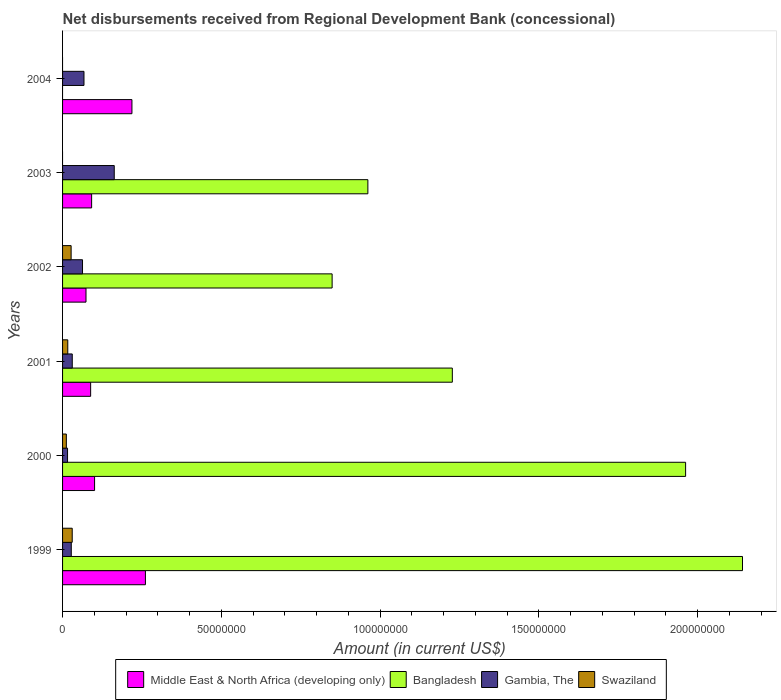Are the number of bars on each tick of the Y-axis equal?
Give a very brief answer. No. How many bars are there on the 4th tick from the bottom?
Your answer should be compact. 4. What is the label of the 6th group of bars from the top?
Your answer should be compact. 1999. In how many cases, is the number of bars for a given year not equal to the number of legend labels?
Keep it short and to the point. 2. What is the amount of disbursements received from Regional Development Bank in Middle East & North Africa (developing only) in 1999?
Your answer should be very brief. 2.61e+07. Across all years, what is the maximum amount of disbursements received from Regional Development Bank in Swaziland?
Your answer should be very brief. 3.04e+06. Across all years, what is the minimum amount of disbursements received from Regional Development Bank in Gambia, The?
Ensure brevity in your answer.  1.57e+06. In which year was the amount of disbursements received from Regional Development Bank in Gambia, The maximum?
Offer a very short reply. 2003. What is the total amount of disbursements received from Regional Development Bank in Swaziland in the graph?
Offer a very short reply. 8.57e+06. What is the difference between the amount of disbursements received from Regional Development Bank in Gambia, The in 2001 and that in 2004?
Offer a terse response. -3.69e+06. What is the difference between the amount of disbursements received from Regional Development Bank in Gambia, The in 2004 and the amount of disbursements received from Regional Development Bank in Swaziland in 2001?
Your answer should be very brief. 5.11e+06. What is the average amount of disbursements received from Regional Development Bank in Bangladesh per year?
Keep it short and to the point. 1.19e+08. In the year 2002, what is the difference between the amount of disbursements received from Regional Development Bank in Middle East & North Africa (developing only) and amount of disbursements received from Regional Development Bank in Swaziland?
Keep it short and to the point. 4.68e+06. What is the ratio of the amount of disbursements received from Regional Development Bank in Bangladesh in 2001 to that in 2002?
Your answer should be very brief. 1.45. Is the amount of disbursements received from Regional Development Bank in Gambia, The in 2000 less than that in 2002?
Ensure brevity in your answer.  Yes. What is the difference between the highest and the second highest amount of disbursements received from Regional Development Bank in Gambia, The?
Give a very brief answer. 9.53e+06. What is the difference between the highest and the lowest amount of disbursements received from Regional Development Bank in Bangladesh?
Give a very brief answer. 2.14e+08. Is it the case that in every year, the sum of the amount of disbursements received from Regional Development Bank in Swaziland and amount of disbursements received from Regional Development Bank in Gambia, The is greater than the sum of amount of disbursements received from Regional Development Bank in Middle East & North Africa (developing only) and amount of disbursements received from Regional Development Bank in Bangladesh?
Your answer should be very brief. Yes. How many years are there in the graph?
Your response must be concise. 6. Are the values on the major ticks of X-axis written in scientific E-notation?
Your response must be concise. No. Does the graph contain any zero values?
Make the answer very short. Yes. How many legend labels are there?
Provide a short and direct response. 4. What is the title of the graph?
Offer a very short reply. Net disbursements received from Regional Development Bank (concessional). What is the Amount (in current US$) in Middle East & North Africa (developing only) in 1999?
Your response must be concise. 2.61e+07. What is the Amount (in current US$) in Bangladesh in 1999?
Give a very brief answer. 2.14e+08. What is the Amount (in current US$) in Gambia, The in 1999?
Keep it short and to the point. 2.75e+06. What is the Amount (in current US$) in Swaziland in 1999?
Your answer should be very brief. 3.04e+06. What is the Amount (in current US$) in Middle East & North Africa (developing only) in 2000?
Keep it short and to the point. 1.01e+07. What is the Amount (in current US$) of Bangladesh in 2000?
Ensure brevity in your answer.  1.96e+08. What is the Amount (in current US$) of Gambia, The in 2000?
Give a very brief answer. 1.57e+06. What is the Amount (in current US$) of Swaziland in 2000?
Offer a terse response. 1.19e+06. What is the Amount (in current US$) of Middle East & North Africa (developing only) in 2001?
Offer a terse response. 8.84e+06. What is the Amount (in current US$) in Bangladesh in 2001?
Your response must be concise. 1.23e+08. What is the Amount (in current US$) of Gambia, The in 2001?
Your response must be concise. 3.06e+06. What is the Amount (in current US$) in Swaziland in 2001?
Your answer should be compact. 1.64e+06. What is the Amount (in current US$) of Middle East & North Africa (developing only) in 2002?
Provide a succinct answer. 7.38e+06. What is the Amount (in current US$) of Bangladesh in 2002?
Make the answer very short. 8.49e+07. What is the Amount (in current US$) in Gambia, The in 2002?
Offer a very short reply. 6.28e+06. What is the Amount (in current US$) of Swaziland in 2002?
Ensure brevity in your answer.  2.70e+06. What is the Amount (in current US$) of Middle East & North Africa (developing only) in 2003?
Make the answer very short. 9.15e+06. What is the Amount (in current US$) of Bangladesh in 2003?
Your answer should be compact. 9.61e+07. What is the Amount (in current US$) in Gambia, The in 2003?
Give a very brief answer. 1.63e+07. What is the Amount (in current US$) of Middle East & North Africa (developing only) in 2004?
Your answer should be very brief. 2.18e+07. What is the Amount (in current US$) in Gambia, The in 2004?
Keep it short and to the point. 6.75e+06. What is the Amount (in current US$) in Swaziland in 2004?
Offer a very short reply. 0. Across all years, what is the maximum Amount (in current US$) in Middle East & North Africa (developing only)?
Your answer should be very brief. 2.61e+07. Across all years, what is the maximum Amount (in current US$) of Bangladesh?
Make the answer very short. 2.14e+08. Across all years, what is the maximum Amount (in current US$) in Gambia, The?
Offer a very short reply. 1.63e+07. Across all years, what is the maximum Amount (in current US$) of Swaziland?
Keep it short and to the point. 3.04e+06. Across all years, what is the minimum Amount (in current US$) in Middle East & North Africa (developing only)?
Your response must be concise. 7.38e+06. Across all years, what is the minimum Amount (in current US$) in Bangladesh?
Offer a terse response. 0. Across all years, what is the minimum Amount (in current US$) of Gambia, The?
Your answer should be very brief. 1.57e+06. What is the total Amount (in current US$) in Middle East & North Africa (developing only) in the graph?
Your answer should be very brief. 8.34e+07. What is the total Amount (in current US$) of Bangladesh in the graph?
Your answer should be compact. 7.14e+08. What is the total Amount (in current US$) of Gambia, The in the graph?
Provide a succinct answer. 3.67e+07. What is the total Amount (in current US$) in Swaziland in the graph?
Provide a short and direct response. 8.57e+06. What is the difference between the Amount (in current US$) of Middle East & North Africa (developing only) in 1999 and that in 2000?
Provide a succinct answer. 1.60e+07. What is the difference between the Amount (in current US$) in Bangladesh in 1999 and that in 2000?
Offer a terse response. 1.79e+07. What is the difference between the Amount (in current US$) of Gambia, The in 1999 and that in 2000?
Offer a very short reply. 1.18e+06. What is the difference between the Amount (in current US$) of Swaziland in 1999 and that in 2000?
Provide a succinct answer. 1.85e+06. What is the difference between the Amount (in current US$) in Middle East & North Africa (developing only) in 1999 and that in 2001?
Ensure brevity in your answer.  1.72e+07. What is the difference between the Amount (in current US$) of Bangladesh in 1999 and that in 2001?
Offer a very short reply. 9.14e+07. What is the difference between the Amount (in current US$) of Gambia, The in 1999 and that in 2001?
Keep it short and to the point. -3.10e+05. What is the difference between the Amount (in current US$) of Swaziland in 1999 and that in 2001?
Your answer should be very brief. 1.40e+06. What is the difference between the Amount (in current US$) of Middle East & North Africa (developing only) in 1999 and that in 2002?
Your response must be concise. 1.87e+07. What is the difference between the Amount (in current US$) in Bangladesh in 1999 and that in 2002?
Provide a short and direct response. 1.29e+08. What is the difference between the Amount (in current US$) in Gambia, The in 1999 and that in 2002?
Make the answer very short. -3.54e+06. What is the difference between the Amount (in current US$) in Swaziland in 1999 and that in 2002?
Offer a very short reply. 3.47e+05. What is the difference between the Amount (in current US$) in Middle East & North Africa (developing only) in 1999 and that in 2003?
Provide a short and direct response. 1.69e+07. What is the difference between the Amount (in current US$) of Bangladesh in 1999 and that in 2003?
Give a very brief answer. 1.18e+08. What is the difference between the Amount (in current US$) in Gambia, The in 1999 and that in 2003?
Make the answer very short. -1.35e+07. What is the difference between the Amount (in current US$) of Middle East & North Africa (developing only) in 1999 and that in 2004?
Offer a very short reply. 4.25e+06. What is the difference between the Amount (in current US$) of Gambia, The in 1999 and that in 2004?
Offer a terse response. -4.00e+06. What is the difference between the Amount (in current US$) in Middle East & North Africa (developing only) in 2000 and that in 2001?
Your answer should be compact. 1.24e+06. What is the difference between the Amount (in current US$) in Bangladesh in 2000 and that in 2001?
Your answer should be very brief. 7.35e+07. What is the difference between the Amount (in current US$) in Gambia, The in 2000 and that in 2001?
Provide a succinct answer. -1.48e+06. What is the difference between the Amount (in current US$) of Swaziland in 2000 and that in 2001?
Provide a short and direct response. -4.48e+05. What is the difference between the Amount (in current US$) in Middle East & North Africa (developing only) in 2000 and that in 2002?
Your answer should be very brief. 2.70e+06. What is the difference between the Amount (in current US$) of Bangladesh in 2000 and that in 2002?
Provide a short and direct response. 1.11e+08. What is the difference between the Amount (in current US$) in Gambia, The in 2000 and that in 2002?
Offer a very short reply. -4.71e+06. What is the difference between the Amount (in current US$) of Swaziland in 2000 and that in 2002?
Your answer should be compact. -1.50e+06. What is the difference between the Amount (in current US$) of Middle East & North Africa (developing only) in 2000 and that in 2003?
Give a very brief answer. 9.26e+05. What is the difference between the Amount (in current US$) of Bangladesh in 2000 and that in 2003?
Offer a very short reply. 1.00e+08. What is the difference between the Amount (in current US$) in Gambia, The in 2000 and that in 2003?
Make the answer very short. -1.47e+07. What is the difference between the Amount (in current US$) of Middle East & North Africa (developing only) in 2000 and that in 2004?
Offer a terse response. -1.18e+07. What is the difference between the Amount (in current US$) in Gambia, The in 2000 and that in 2004?
Provide a succinct answer. -5.18e+06. What is the difference between the Amount (in current US$) of Middle East & North Africa (developing only) in 2001 and that in 2002?
Your answer should be very brief. 1.46e+06. What is the difference between the Amount (in current US$) in Bangladesh in 2001 and that in 2002?
Your answer should be compact. 3.79e+07. What is the difference between the Amount (in current US$) of Gambia, The in 2001 and that in 2002?
Your answer should be compact. -3.22e+06. What is the difference between the Amount (in current US$) in Swaziland in 2001 and that in 2002?
Give a very brief answer. -1.06e+06. What is the difference between the Amount (in current US$) in Middle East & North Africa (developing only) in 2001 and that in 2003?
Ensure brevity in your answer.  -3.10e+05. What is the difference between the Amount (in current US$) of Bangladesh in 2001 and that in 2003?
Make the answer very short. 2.66e+07. What is the difference between the Amount (in current US$) of Gambia, The in 2001 and that in 2003?
Make the answer very short. -1.32e+07. What is the difference between the Amount (in current US$) of Middle East & North Africa (developing only) in 2001 and that in 2004?
Offer a terse response. -1.30e+07. What is the difference between the Amount (in current US$) in Gambia, The in 2001 and that in 2004?
Make the answer very short. -3.69e+06. What is the difference between the Amount (in current US$) of Middle East & North Africa (developing only) in 2002 and that in 2003?
Provide a short and direct response. -1.77e+06. What is the difference between the Amount (in current US$) of Bangladesh in 2002 and that in 2003?
Make the answer very short. -1.13e+07. What is the difference between the Amount (in current US$) of Gambia, The in 2002 and that in 2003?
Your answer should be compact. -9.99e+06. What is the difference between the Amount (in current US$) of Middle East & North Africa (developing only) in 2002 and that in 2004?
Your answer should be compact. -1.45e+07. What is the difference between the Amount (in current US$) in Gambia, The in 2002 and that in 2004?
Offer a terse response. -4.66e+05. What is the difference between the Amount (in current US$) in Middle East & North Africa (developing only) in 2003 and that in 2004?
Your answer should be compact. -1.27e+07. What is the difference between the Amount (in current US$) in Gambia, The in 2003 and that in 2004?
Your answer should be very brief. 9.53e+06. What is the difference between the Amount (in current US$) in Middle East & North Africa (developing only) in 1999 and the Amount (in current US$) in Bangladesh in 2000?
Your response must be concise. -1.70e+08. What is the difference between the Amount (in current US$) in Middle East & North Africa (developing only) in 1999 and the Amount (in current US$) in Gambia, The in 2000?
Provide a short and direct response. 2.45e+07. What is the difference between the Amount (in current US$) in Middle East & North Africa (developing only) in 1999 and the Amount (in current US$) in Swaziland in 2000?
Provide a short and direct response. 2.49e+07. What is the difference between the Amount (in current US$) of Bangladesh in 1999 and the Amount (in current US$) of Gambia, The in 2000?
Your answer should be very brief. 2.13e+08. What is the difference between the Amount (in current US$) in Bangladesh in 1999 and the Amount (in current US$) in Swaziland in 2000?
Ensure brevity in your answer.  2.13e+08. What is the difference between the Amount (in current US$) of Gambia, The in 1999 and the Amount (in current US$) of Swaziland in 2000?
Keep it short and to the point. 1.55e+06. What is the difference between the Amount (in current US$) in Middle East & North Africa (developing only) in 1999 and the Amount (in current US$) in Bangladesh in 2001?
Provide a short and direct response. -9.66e+07. What is the difference between the Amount (in current US$) of Middle East & North Africa (developing only) in 1999 and the Amount (in current US$) of Gambia, The in 2001?
Your answer should be very brief. 2.30e+07. What is the difference between the Amount (in current US$) in Middle East & North Africa (developing only) in 1999 and the Amount (in current US$) in Swaziland in 2001?
Offer a very short reply. 2.45e+07. What is the difference between the Amount (in current US$) in Bangladesh in 1999 and the Amount (in current US$) in Gambia, The in 2001?
Your answer should be very brief. 2.11e+08. What is the difference between the Amount (in current US$) in Bangladesh in 1999 and the Amount (in current US$) in Swaziland in 2001?
Offer a very short reply. 2.12e+08. What is the difference between the Amount (in current US$) of Gambia, The in 1999 and the Amount (in current US$) of Swaziland in 2001?
Keep it short and to the point. 1.11e+06. What is the difference between the Amount (in current US$) of Middle East & North Africa (developing only) in 1999 and the Amount (in current US$) of Bangladesh in 2002?
Your response must be concise. -5.88e+07. What is the difference between the Amount (in current US$) of Middle East & North Africa (developing only) in 1999 and the Amount (in current US$) of Gambia, The in 2002?
Provide a succinct answer. 1.98e+07. What is the difference between the Amount (in current US$) in Middle East & North Africa (developing only) in 1999 and the Amount (in current US$) in Swaziland in 2002?
Keep it short and to the point. 2.34e+07. What is the difference between the Amount (in current US$) in Bangladesh in 1999 and the Amount (in current US$) in Gambia, The in 2002?
Provide a succinct answer. 2.08e+08. What is the difference between the Amount (in current US$) in Bangladesh in 1999 and the Amount (in current US$) in Swaziland in 2002?
Provide a succinct answer. 2.11e+08. What is the difference between the Amount (in current US$) in Gambia, The in 1999 and the Amount (in current US$) in Swaziland in 2002?
Your response must be concise. 5.10e+04. What is the difference between the Amount (in current US$) of Middle East & North Africa (developing only) in 1999 and the Amount (in current US$) of Bangladesh in 2003?
Provide a succinct answer. -7.01e+07. What is the difference between the Amount (in current US$) in Middle East & North Africa (developing only) in 1999 and the Amount (in current US$) in Gambia, The in 2003?
Ensure brevity in your answer.  9.82e+06. What is the difference between the Amount (in current US$) in Bangladesh in 1999 and the Amount (in current US$) in Gambia, The in 2003?
Offer a very short reply. 1.98e+08. What is the difference between the Amount (in current US$) of Middle East & North Africa (developing only) in 1999 and the Amount (in current US$) of Gambia, The in 2004?
Provide a short and direct response. 1.93e+07. What is the difference between the Amount (in current US$) in Bangladesh in 1999 and the Amount (in current US$) in Gambia, The in 2004?
Give a very brief answer. 2.07e+08. What is the difference between the Amount (in current US$) of Middle East & North Africa (developing only) in 2000 and the Amount (in current US$) of Bangladesh in 2001?
Your answer should be very brief. -1.13e+08. What is the difference between the Amount (in current US$) of Middle East & North Africa (developing only) in 2000 and the Amount (in current US$) of Gambia, The in 2001?
Make the answer very short. 7.02e+06. What is the difference between the Amount (in current US$) in Middle East & North Africa (developing only) in 2000 and the Amount (in current US$) in Swaziland in 2001?
Offer a terse response. 8.44e+06. What is the difference between the Amount (in current US$) of Bangladesh in 2000 and the Amount (in current US$) of Gambia, The in 2001?
Give a very brief answer. 1.93e+08. What is the difference between the Amount (in current US$) of Bangladesh in 2000 and the Amount (in current US$) of Swaziland in 2001?
Offer a very short reply. 1.95e+08. What is the difference between the Amount (in current US$) of Gambia, The in 2000 and the Amount (in current US$) of Swaziland in 2001?
Make the answer very short. -6.90e+04. What is the difference between the Amount (in current US$) of Middle East & North Africa (developing only) in 2000 and the Amount (in current US$) of Bangladesh in 2002?
Make the answer very short. -7.48e+07. What is the difference between the Amount (in current US$) in Middle East & North Africa (developing only) in 2000 and the Amount (in current US$) in Gambia, The in 2002?
Give a very brief answer. 3.80e+06. What is the difference between the Amount (in current US$) of Middle East & North Africa (developing only) in 2000 and the Amount (in current US$) of Swaziland in 2002?
Your answer should be compact. 7.38e+06. What is the difference between the Amount (in current US$) in Bangladesh in 2000 and the Amount (in current US$) in Gambia, The in 2002?
Ensure brevity in your answer.  1.90e+08. What is the difference between the Amount (in current US$) of Bangladesh in 2000 and the Amount (in current US$) of Swaziland in 2002?
Offer a terse response. 1.94e+08. What is the difference between the Amount (in current US$) in Gambia, The in 2000 and the Amount (in current US$) in Swaziland in 2002?
Provide a short and direct response. -1.12e+06. What is the difference between the Amount (in current US$) in Middle East & North Africa (developing only) in 2000 and the Amount (in current US$) in Bangladesh in 2003?
Ensure brevity in your answer.  -8.61e+07. What is the difference between the Amount (in current US$) of Middle East & North Africa (developing only) in 2000 and the Amount (in current US$) of Gambia, The in 2003?
Offer a very short reply. -6.20e+06. What is the difference between the Amount (in current US$) in Bangladesh in 2000 and the Amount (in current US$) in Gambia, The in 2003?
Your response must be concise. 1.80e+08. What is the difference between the Amount (in current US$) of Middle East & North Africa (developing only) in 2000 and the Amount (in current US$) of Gambia, The in 2004?
Your answer should be compact. 3.33e+06. What is the difference between the Amount (in current US$) of Bangladesh in 2000 and the Amount (in current US$) of Gambia, The in 2004?
Offer a very short reply. 1.89e+08. What is the difference between the Amount (in current US$) of Middle East & North Africa (developing only) in 2001 and the Amount (in current US$) of Bangladesh in 2002?
Offer a very short reply. -7.60e+07. What is the difference between the Amount (in current US$) in Middle East & North Africa (developing only) in 2001 and the Amount (in current US$) in Gambia, The in 2002?
Provide a succinct answer. 2.56e+06. What is the difference between the Amount (in current US$) of Middle East & North Africa (developing only) in 2001 and the Amount (in current US$) of Swaziland in 2002?
Your answer should be compact. 6.15e+06. What is the difference between the Amount (in current US$) of Bangladesh in 2001 and the Amount (in current US$) of Gambia, The in 2002?
Provide a short and direct response. 1.16e+08. What is the difference between the Amount (in current US$) in Bangladesh in 2001 and the Amount (in current US$) in Swaziland in 2002?
Your response must be concise. 1.20e+08. What is the difference between the Amount (in current US$) of Gambia, The in 2001 and the Amount (in current US$) of Swaziland in 2002?
Give a very brief answer. 3.61e+05. What is the difference between the Amount (in current US$) in Middle East & North Africa (developing only) in 2001 and the Amount (in current US$) in Bangladesh in 2003?
Your answer should be very brief. -8.73e+07. What is the difference between the Amount (in current US$) in Middle East & North Africa (developing only) in 2001 and the Amount (in current US$) in Gambia, The in 2003?
Provide a succinct answer. -7.43e+06. What is the difference between the Amount (in current US$) of Bangladesh in 2001 and the Amount (in current US$) of Gambia, The in 2003?
Your answer should be compact. 1.06e+08. What is the difference between the Amount (in current US$) of Middle East & North Africa (developing only) in 2001 and the Amount (in current US$) of Gambia, The in 2004?
Ensure brevity in your answer.  2.10e+06. What is the difference between the Amount (in current US$) of Bangladesh in 2001 and the Amount (in current US$) of Gambia, The in 2004?
Ensure brevity in your answer.  1.16e+08. What is the difference between the Amount (in current US$) in Middle East & North Africa (developing only) in 2002 and the Amount (in current US$) in Bangladesh in 2003?
Provide a succinct answer. -8.88e+07. What is the difference between the Amount (in current US$) in Middle East & North Africa (developing only) in 2002 and the Amount (in current US$) in Gambia, The in 2003?
Give a very brief answer. -8.90e+06. What is the difference between the Amount (in current US$) of Bangladesh in 2002 and the Amount (in current US$) of Gambia, The in 2003?
Make the answer very short. 6.86e+07. What is the difference between the Amount (in current US$) of Middle East & North Africa (developing only) in 2002 and the Amount (in current US$) of Gambia, The in 2004?
Provide a succinct answer. 6.32e+05. What is the difference between the Amount (in current US$) in Bangladesh in 2002 and the Amount (in current US$) in Gambia, The in 2004?
Offer a very short reply. 7.81e+07. What is the difference between the Amount (in current US$) in Middle East & North Africa (developing only) in 2003 and the Amount (in current US$) in Gambia, The in 2004?
Provide a short and direct response. 2.41e+06. What is the difference between the Amount (in current US$) of Bangladesh in 2003 and the Amount (in current US$) of Gambia, The in 2004?
Your answer should be compact. 8.94e+07. What is the average Amount (in current US$) of Middle East & North Africa (developing only) per year?
Keep it short and to the point. 1.39e+07. What is the average Amount (in current US$) in Bangladesh per year?
Ensure brevity in your answer.  1.19e+08. What is the average Amount (in current US$) in Gambia, The per year?
Make the answer very short. 6.11e+06. What is the average Amount (in current US$) of Swaziland per year?
Your response must be concise. 1.43e+06. In the year 1999, what is the difference between the Amount (in current US$) in Middle East & North Africa (developing only) and Amount (in current US$) in Bangladesh?
Make the answer very short. -1.88e+08. In the year 1999, what is the difference between the Amount (in current US$) in Middle East & North Africa (developing only) and Amount (in current US$) in Gambia, The?
Provide a succinct answer. 2.33e+07. In the year 1999, what is the difference between the Amount (in current US$) of Middle East & North Africa (developing only) and Amount (in current US$) of Swaziland?
Make the answer very short. 2.31e+07. In the year 1999, what is the difference between the Amount (in current US$) of Bangladesh and Amount (in current US$) of Gambia, The?
Your answer should be very brief. 2.11e+08. In the year 1999, what is the difference between the Amount (in current US$) of Bangladesh and Amount (in current US$) of Swaziland?
Make the answer very short. 2.11e+08. In the year 1999, what is the difference between the Amount (in current US$) in Gambia, The and Amount (in current US$) in Swaziland?
Provide a short and direct response. -2.96e+05. In the year 2000, what is the difference between the Amount (in current US$) of Middle East & North Africa (developing only) and Amount (in current US$) of Bangladesh?
Ensure brevity in your answer.  -1.86e+08. In the year 2000, what is the difference between the Amount (in current US$) of Middle East & North Africa (developing only) and Amount (in current US$) of Gambia, The?
Give a very brief answer. 8.51e+06. In the year 2000, what is the difference between the Amount (in current US$) of Middle East & North Africa (developing only) and Amount (in current US$) of Swaziland?
Keep it short and to the point. 8.89e+06. In the year 2000, what is the difference between the Amount (in current US$) of Bangladesh and Amount (in current US$) of Gambia, The?
Offer a very short reply. 1.95e+08. In the year 2000, what is the difference between the Amount (in current US$) in Bangladesh and Amount (in current US$) in Swaziland?
Provide a succinct answer. 1.95e+08. In the year 2000, what is the difference between the Amount (in current US$) in Gambia, The and Amount (in current US$) in Swaziland?
Offer a terse response. 3.79e+05. In the year 2001, what is the difference between the Amount (in current US$) in Middle East & North Africa (developing only) and Amount (in current US$) in Bangladesh?
Your response must be concise. -1.14e+08. In the year 2001, what is the difference between the Amount (in current US$) of Middle East & North Africa (developing only) and Amount (in current US$) of Gambia, The?
Your answer should be compact. 5.79e+06. In the year 2001, what is the difference between the Amount (in current US$) of Middle East & North Africa (developing only) and Amount (in current US$) of Swaziland?
Provide a succinct answer. 7.20e+06. In the year 2001, what is the difference between the Amount (in current US$) in Bangladesh and Amount (in current US$) in Gambia, The?
Offer a terse response. 1.20e+08. In the year 2001, what is the difference between the Amount (in current US$) of Bangladesh and Amount (in current US$) of Swaziland?
Provide a short and direct response. 1.21e+08. In the year 2001, what is the difference between the Amount (in current US$) in Gambia, The and Amount (in current US$) in Swaziland?
Your response must be concise. 1.42e+06. In the year 2002, what is the difference between the Amount (in current US$) in Middle East & North Africa (developing only) and Amount (in current US$) in Bangladesh?
Keep it short and to the point. -7.75e+07. In the year 2002, what is the difference between the Amount (in current US$) in Middle East & North Africa (developing only) and Amount (in current US$) in Gambia, The?
Keep it short and to the point. 1.10e+06. In the year 2002, what is the difference between the Amount (in current US$) of Middle East & North Africa (developing only) and Amount (in current US$) of Swaziland?
Provide a short and direct response. 4.68e+06. In the year 2002, what is the difference between the Amount (in current US$) of Bangladesh and Amount (in current US$) of Gambia, The?
Keep it short and to the point. 7.86e+07. In the year 2002, what is the difference between the Amount (in current US$) of Bangladesh and Amount (in current US$) of Swaziland?
Offer a terse response. 8.22e+07. In the year 2002, what is the difference between the Amount (in current US$) of Gambia, The and Amount (in current US$) of Swaziland?
Keep it short and to the point. 3.59e+06. In the year 2003, what is the difference between the Amount (in current US$) in Middle East & North Africa (developing only) and Amount (in current US$) in Bangladesh?
Provide a short and direct response. -8.70e+07. In the year 2003, what is the difference between the Amount (in current US$) of Middle East & North Africa (developing only) and Amount (in current US$) of Gambia, The?
Keep it short and to the point. -7.12e+06. In the year 2003, what is the difference between the Amount (in current US$) of Bangladesh and Amount (in current US$) of Gambia, The?
Keep it short and to the point. 7.99e+07. In the year 2004, what is the difference between the Amount (in current US$) in Middle East & North Africa (developing only) and Amount (in current US$) in Gambia, The?
Give a very brief answer. 1.51e+07. What is the ratio of the Amount (in current US$) of Middle East & North Africa (developing only) in 1999 to that in 2000?
Give a very brief answer. 2.59. What is the ratio of the Amount (in current US$) in Bangladesh in 1999 to that in 2000?
Provide a succinct answer. 1.09. What is the ratio of the Amount (in current US$) in Gambia, The in 1999 to that in 2000?
Provide a short and direct response. 1.75. What is the ratio of the Amount (in current US$) of Swaziland in 1999 to that in 2000?
Offer a very short reply. 2.55. What is the ratio of the Amount (in current US$) in Middle East & North Africa (developing only) in 1999 to that in 2001?
Your answer should be compact. 2.95. What is the ratio of the Amount (in current US$) in Bangladesh in 1999 to that in 2001?
Make the answer very short. 1.74. What is the ratio of the Amount (in current US$) of Gambia, The in 1999 to that in 2001?
Provide a short and direct response. 0.9. What is the ratio of the Amount (in current US$) of Swaziland in 1999 to that in 2001?
Give a very brief answer. 1.85. What is the ratio of the Amount (in current US$) of Middle East & North Africa (developing only) in 1999 to that in 2002?
Your answer should be very brief. 3.54. What is the ratio of the Amount (in current US$) in Bangladesh in 1999 to that in 2002?
Offer a very short reply. 2.52. What is the ratio of the Amount (in current US$) of Gambia, The in 1999 to that in 2002?
Your answer should be very brief. 0.44. What is the ratio of the Amount (in current US$) in Swaziland in 1999 to that in 2002?
Provide a succinct answer. 1.13. What is the ratio of the Amount (in current US$) of Middle East & North Africa (developing only) in 1999 to that in 2003?
Offer a very short reply. 2.85. What is the ratio of the Amount (in current US$) of Bangladesh in 1999 to that in 2003?
Give a very brief answer. 2.23. What is the ratio of the Amount (in current US$) in Gambia, The in 1999 to that in 2003?
Offer a very short reply. 0.17. What is the ratio of the Amount (in current US$) in Middle East & North Africa (developing only) in 1999 to that in 2004?
Offer a terse response. 1.19. What is the ratio of the Amount (in current US$) in Gambia, The in 1999 to that in 2004?
Give a very brief answer. 0.41. What is the ratio of the Amount (in current US$) of Middle East & North Africa (developing only) in 2000 to that in 2001?
Give a very brief answer. 1.14. What is the ratio of the Amount (in current US$) of Bangladesh in 2000 to that in 2001?
Provide a succinct answer. 1.6. What is the ratio of the Amount (in current US$) in Gambia, The in 2000 to that in 2001?
Offer a terse response. 0.51. What is the ratio of the Amount (in current US$) of Swaziland in 2000 to that in 2001?
Your answer should be compact. 0.73. What is the ratio of the Amount (in current US$) of Middle East & North Africa (developing only) in 2000 to that in 2002?
Provide a succinct answer. 1.37. What is the ratio of the Amount (in current US$) in Bangladesh in 2000 to that in 2002?
Make the answer very short. 2.31. What is the ratio of the Amount (in current US$) of Gambia, The in 2000 to that in 2002?
Ensure brevity in your answer.  0.25. What is the ratio of the Amount (in current US$) in Swaziland in 2000 to that in 2002?
Give a very brief answer. 0.44. What is the ratio of the Amount (in current US$) in Middle East & North Africa (developing only) in 2000 to that in 2003?
Give a very brief answer. 1.1. What is the ratio of the Amount (in current US$) of Bangladesh in 2000 to that in 2003?
Make the answer very short. 2.04. What is the ratio of the Amount (in current US$) of Gambia, The in 2000 to that in 2003?
Your answer should be compact. 0.1. What is the ratio of the Amount (in current US$) in Middle East & North Africa (developing only) in 2000 to that in 2004?
Make the answer very short. 0.46. What is the ratio of the Amount (in current US$) of Gambia, The in 2000 to that in 2004?
Your response must be concise. 0.23. What is the ratio of the Amount (in current US$) in Middle East & North Africa (developing only) in 2001 to that in 2002?
Make the answer very short. 1.2. What is the ratio of the Amount (in current US$) in Bangladesh in 2001 to that in 2002?
Provide a succinct answer. 1.45. What is the ratio of the Amount (in current US$) in Gambia, The in 2001 to that in 2002?
Give a very brief answer. 0.49. What is the ratio of the Amount (in current US$) of Swaziland in 2001 to that in 2002?
Your answer should be compact. 0.61. What is the ratio of the Amount (in current US$) of Middle East & North Africa (developing only) in 2001 to that in 2003?
Provide a short and direct response. 0.97. What is the ratio of the Amount (in current US$) in Bangladesh in 2001 to that in 2003?
Offer a very short reply. 1.28. What is the ratio of the Amount (in current US$) of Gambia, The in 2001 to that in 2003?
Provide a short and direct response. 0.19. What is the ratio of the Amount (in current US$) in Middle East & North Africa (developing only) in 2001 to that in 2004?
Make the answer very short. 0.4. What is the ratio of the Amount (in current US$) of Gambia, The in 2001 to that in 2004?
Your answer should be very brief. 0.45. What is the ratio of the Amount (in current US$) in Middle East & North Africa (developing only) in 2002 to that in 2003?
Offer a very short reply. 0.81. What is the ratio of the Amount (in current US$) in Bangladesh in 2002 to that in 2003?
Provide a short and direct response. 0.88. What is the ratio of the Amount (in current US$) of Gambia, The in 2002 to that in 2003?
Ensure brevity in your answer.  0.39. What is the ratio of the Amount (in current US$) of Middle East & North Africa (developing only) in 2002 to that in 2004?
Provide a short and direct response. 0.34. What is the ratio of the Amount (in current US$) of Gambia, The in 2002 to that in 2004?
Give a very brief answer. 0.93. What is the ratio of the Amount (in current US$) in Middle East & North Africa (developing only) in 2003 to that in 2004?
Offer a terse response. 0.42. What is the ratio of the Amount (in current US$) of Gambia, The in 2003 to that in 2004?
Ensure brevity in your answer.  2.41. What is the difference between the highest and the second highest Amount (in current US$) of Middle East & North Africa (developing only)?
Make the answer very short. 4.25e+06. What is the difference between the highest and the second highest Amount (in current US$) of Bangladesh?
Make the answer very short. 1.79e+07. What is the difference between the highest and the second highest Amount (in current US$) of Gambia, The?
Make the answer very short. 9.53e+06. What is the difference between the highest and the second highest Amount (in current US$) of Swaziland?
Offer a terse response. 3.47e+05. What is the difference between the highest and the lowest Amount (in current US$) in Middle East & North Africa (developing only)?
Your response must be concise. 1.87e+07. What is the difference between the highest and the lowest Amount (in current US$) of Bangladesh?
Provide a succinct answer. 2.14e+08. What is the difference between the highest and the lowest Amount (in current US$) in Gambia, The?
Provide a succinct answer. 1.47e+07. What is the difference between the highest and the lowest Amount (in current US$) in Swaziland?
Provide a succinct answer. 3.04e+06. 